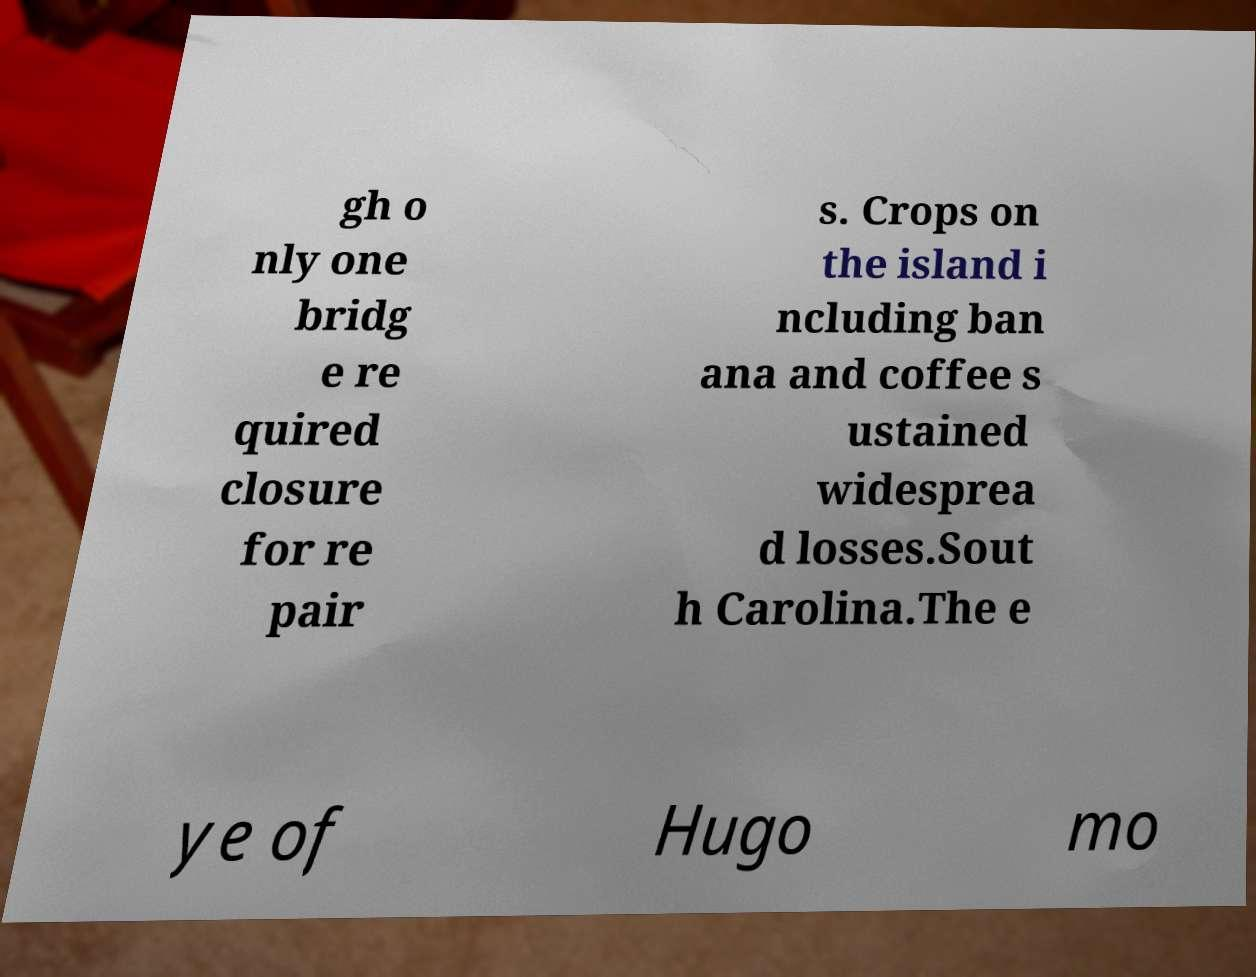What messages or text are displayed in this image? I need them in a readable, typed format. gh o nly one bridg e re quired closure for re pair s. Crops on the island i ncluding ban ana and coffee s ustained widesprea d losses.Sout h Carolina.The e ye of Hugo mo 